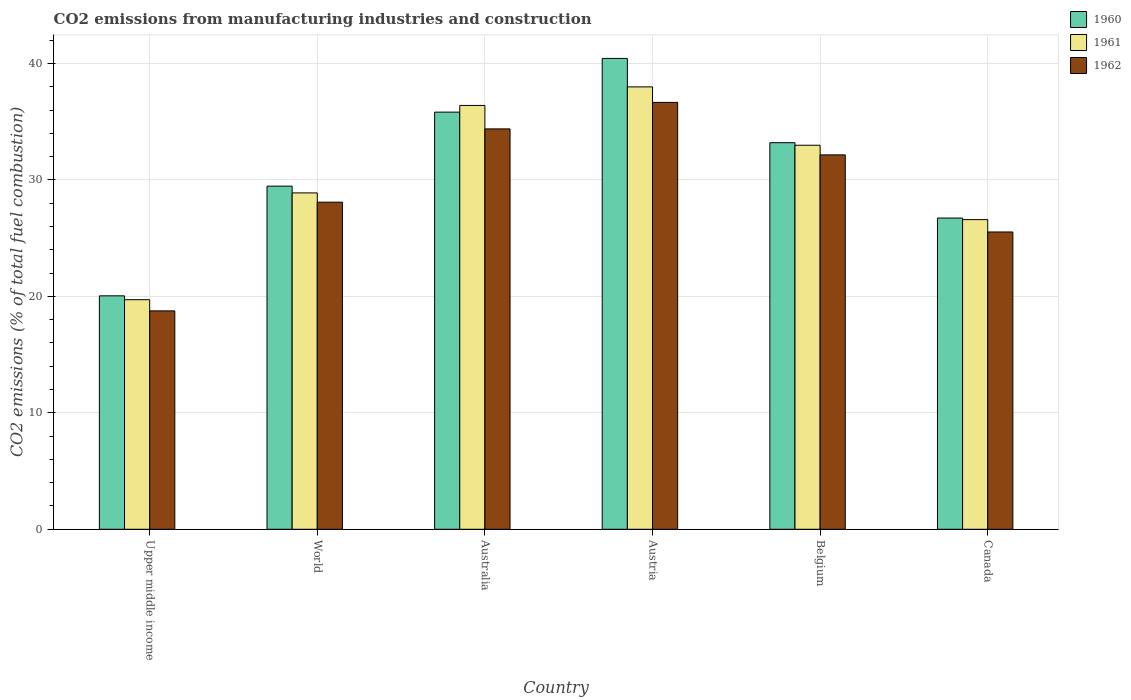How many different coloured bars are there?
Ensure brevity in your answer.  3. How many groups of bars are there?
Offer a very short reply. 6. Are the number of bars on each tick of the X-axis equal?
Provide a succinct answer. Yes. What is the amount of CO2 emitted in 1960 in Australia?
Your response must be concise. 35.83. Across all countries, what is the maximum amount of CO2 emitted in 1960?
Your answer should be compact. 40.44. Across all countries, what is the minimum amount of CO2 emitted in 1960?
Keep it short and to the point. 20.05. In which country was the amount of CO2 emitted in 1962 minimum?
Your answer should be very brief. Upper middle income. What is the total amount of CO2 emitted in 1961 in the graph?
Your answer should be very brief. 182.58. What is the difference between the amount of CO2 emitted in 1960 in Australia and that in Canada?
Your response must be concise. 9.1. What is the difference between the amount of CO2 emitted in 1962 in Australia and the amount of CO2 emitted in 1960 in Canada?
Provide a succinct answer. 7.65. What is the average amount of CO2 emitted in 1960 per country?
Make the answer very short. 30.95. What is the difference between the amount of CO2 emitted of/in 1962 and amount of CO2 emitted of/in 1960 in Austria?
Your response must be concise. -3.78. What is the ratio of the amount of CO2 emitted in 1961 in Australia to that in Austria?
Make the answer very short. 0.96. Is the difference between the amount of CO2 emitted in 1962 in Austria and Upper middle income greater than the difference between the amount of CO2 emitted in 1960 in Austria and Upper middle income?
Offer a terse response. No. What is the difference between the highest and the second highest amount of CO2 emitted in 1961?
Provide a succinct answer. -3.42. What is the difference between the highest and the lowest amount of CO2 emitted in 1962?
Your response must be concise. 17.9. In how many countries, is the amount of CO2 emitted in 1961 greater than the average amount of CO2 emitted in 1961 taken over all countries?
Provide a succinct answer. 3. What does the 2nd bar from the left in Australia represents?
Offer a very short reply. 1961. How many bars are there?
Provide a succinct answer. 18. Are all the bars in the graph horizontal?
Your answer should be very brief. No. How many countries are there in the graph?
Provide a succinct answer. 6. Does the graph contain grids?
Give a very brief answer. Yes. How are the legend labels stacked?
Provide a succinct answer. Vertical. What is the title of the graph?
Offer a terse response. CO2 emissions from manufacturing industries and construction. Does "2012" appear as one of the legend labels in the graph?
Provide a short and direct response. No. What is the label or title of the X-axis?
Make the answer very short. Country. What is the label or title of the Y-axis?
Give a very brief answer. CO2 emissions (% of total fuel combustion). What is the CO2 emissions (% of total fuel combustion) in 1960 in Upper middle income?
Your response must be concise. 20.05. What is the CO2 emissions (% of total fuel combustion) of 1961 in Upper middle income?
Your response must be concise. 19.72. What is the CO2 emissions (% of total fuel combustion) in 1962 in Upper middle income?
Provide a succinct answer. 18.76. What is the CO2 emissions (% of total fuel combustion) in 1960 in World?
Your response must be concise. 29.47. What is the CO2 emissions (% of total fuel combustion) of 1961 in World?
Provide a short and direct response. 28.89. What is the CO2 emissions (% of total fuel combustion) in 1962 in World?
Make the answer very short. 28.09. What is the CO2 emissions (% of total fuel combustion) in 1960 in Australia?
Ensure brevity in your answer.  35.83. What is the CO2 emissions (% of total fuel combustion) of 1961 in Australia?
Make the answer very short. 36.4. What is the CO2 emissions (% of total fuel combustion) in 1962 in Australia?
Your answer should be very brief. 34.39. What is the CO2 emissions (% of total fuel combustion) in 1960 in Austria?
Offer a very short reply. 40.44. What is the CO2 emissions (% of total fuel combustion) in 1961 in Austria?
Make the answer very short. 37.99. What is the CO2 emissions (% of total fuel combustion) of 1962 in Austria?
Your response must be concise. 36.66. What is the CO2 emissions (% of total fuel combustion) of 1960 in Belgium?
Your answer should be compact. 33.2. What is the CO2 emissions (% of total fuel combustion) in 1961 in Belgium?
Make the answer very short. 32.98. What is the CO2 emissions (% of total fuel combustion) of 1962 in Belgium?
Offer a very short reply. 32.16. What is the CO2 emissions (% of total fuel combustion) in 1960 in Canada?
Your answer should be compact. 26.73. What is the CO2 emissions (% of total fuel combustion) in 1961 in Canada?
Your response must be concise. 26.59. What is the CO2 emissions (% of total fuel combustion) of 1962 in Canada?
Provide a short and direct response. 25.53. Across all countries, what is the maximum CO2 emissions (% of total fuel combustion) in 1960?
Offer a very short reply. 40.44. Across all countries, what is the maximum CO2 emissions (% of total fuel combustion) in 1961?
Your answer should be compact. 37.99. Across all countries, what is the maximum CO2 emissions (% of total fuel combustion) in 1962?
Offer a terse response. 36.66. Across all countries, what is the minimum CO2 emissions (% of total fuel combustion) of 1960?
Provide a succinct answer. 20.05. Across all countries, what is the minimum CO2 emissions (% of total fuel combustion) in 1961?
Your answer should be compact. 19.72. Across all countries, what is the minimum CO2 emissions (% of total fuel combustion) of 1962?
Offer a very short reply. 18.76. What is the total CO2 emissions (% of total fuel combustion) in 1960 in the graph?
Give a very brief answer. 185.71. What is the total CO2 emissions (% of total fuel combustion) in 1961 in the graph?
Your response must be concise. 182.58. What is the total CO2 emissions (% of total fuel combustion) in 1962 in the graph?
Offer a very short reply. 175.59. What is the difference between the CO2 emissions (% of total fuel combustion) in 1960 in Upper middle income and that in World?
Make the answer very short. -9.42. What is the difference between the CO2 emissions (% of total fuel combustion) of 1961 in Upper middle income and that in World?
Your response must be concise. -9.17. What is the difference between the CO2 emissions (% of total fuel combustion) of 1962 in Upper middle income and that in World?
Offer a very short reply. -9.34. What is the difference between the CO2 emissions (% of total fuel combustion) in 1960 in Upper middle income and that in Australia?
Give a very brief answer. -15.78. What is the difference between the CO2 emissions (% of total fuel combustion) of 1961 in Upper middle income and that in Australia?
Offer a terse response. -16.68. What is the difference between the CO2 emissions (% of total fuel combustion) in 1962 in Upper middle income and that in Australia?
Provide a succinct answer. -15.63. What is the difference between the CO2 emissions (% of total fuel combustion) of 1960 in Upper middle income and that in Austria?
Offer a terse response. -20.39. What is the difference between the CO2 emissions (% of total fuel combustion) in 1961 in Upper middle income and that in Austria?
Your response must be concise. -18.28. What is the difference between the CO2 emissions (% of total fuel combustion) in 1962 in Upper middle income and that in Austria?
Offer a very short reply. -17.9. What is the difference between the CO2 emissions (% of total fuel combustion) in 1960 in Upper middle income and that in Belgium?
Make the answer very short. -13.15. What is the difference between the CO2 emissions (% of total fuel combustion) of 1961 in Upper middle income and that in Belgium?
Your response must be concise. -13.27. What is the difference between the CO2 emissions (% of total fuel combustion) of 1962 in Upper middle income and that in Belgium?
Offer a very short reply. -13.4. What is the difference between the CO2 emissions (% of total fuel combustion) in 1960 in Upper middle income and that in Canada?
Your response must be concise. -6.68. What is the difference between the CO2 emissions (% of total fuel combustion) in 1961 in Upper middle income and that in Canada?
Your answer should be compact. -6.88. What is the difference between the CO2 emissions (% of total fuel combustion) in 1962 in Upper middle income and that in Canada?
Give a very brief answer. -6.78. What is the difference between the CO2 emissions (% of total fuel combustion) of 1960 in World and that in Australia?
Your answer should be very brief. -6.36. What is the difference between the CO2 emissions (% of total fuel combustion) of 1961 in World and that in Australia?
Provide a short and direct response. -7.51. What is the difference between the CO2 emissions (% of total fuel combustion) of 1962 in World and that in Australia?
Ensure brevity in your answer.  -6.29. What is the difference between the CO2 emissions (% of total fuel combustion) in 1960 in World and that in Austria?
Your answer should be very brief. -10.97. What is the difference between the CO2 emissions (% of total fuel combustion) in 1961 in World and that in Austria?
Keep it short and to the point. -9.11. What is the difference between the CO2 emissions (% of total fuel combustion) in 1962 in World and that in Austria?
Offer a very short reply. -8.57. What is the difference between the CO2 emissions (% of total fuel combustion) in 1960 in World and that in Belgium?
Ensure brevity in your answer.  -3.73. What is the difference between the CO2 emissions (% of total fuel combustion) of 1961 in World and that in Belgium?
Offer a very short reply. -4.09. What is the difference between the CO2 emissions (% of total fuel combustion) in 1962 in World and that in Belgium?
Your response must be concise. -4.06. What is the difference between the CO2 emissions (% of total fuel combustion) of 1960 in World and that in Canada?
Make the answer very short. 2.74. What is the difference between the CO2 emissions (% of total fuel combustion) in 1961 in World and that in Canada?
Offer a very short reply. 2.29. What is the difference between the CO2 emissions (% of total fuel combustion) in 1962 in World and that in Canada?
Provide a succinct answer. 2.56. What is the difference between the CO2 emissions (% of total fuel combustion) in 1960 in Australia and that in Austria?
Provide a short and direct response. -4.61. What is the difference between the CO2 emissions (% of total fuel combustion) of 1961 in Australia and that in Austria?
Offer a very short reply. -1.6. What is the difference between the CO2 emissions (% of total fuel combustion) in 1962 in Australia and that in Austria?
Give a very brief answer. -2.28. What is the difference between the CO2 emissions (% of total fuel combustion) of 1960 in Australia and that in Belgium?
Offer a terse response. 2.63. What is the difference between the CO2 emissions (% of total fuel combustion) of 1961 in Australia and that in Belgium?
Your response must be concise. 3.42. What is the difference between the CO2 emissions (% of total fuel combustion) in 1962 in Australia and that in Belgium?
Offer a very short reply. 2.23. What is the difference between the CO2 emissions (% of total fuel combustion) of 1960 in Australia and that in Canada?
Your response must be concise. 9.1. What is the difference between the CO2 emissions (% of total fuel combustion) in 1961 in Australia and that in Canada?
Make the answer very short. 9.81. What is the difference between the CO2 emissions (% of total fuel combustion) of 1962 in Australia and that in Canada?
Provide a succinct answer. 8.85. What is the difference between the CO2 emissions (% of total fuel combustion) of 1960 in Austria and that in Belgium?
Ensure brevity in your answer.  7.24. What is the difference between the CO2 emissions (% of total fuel combustion) in 1961 in Austria and that in Belgium?
Your response must be concise. 5.01. What is the difference between the CO2 emissions (% of total fuel combustion) in 1962 in Austria and that in Belgium?
Your response must be concise. 4.51. What is the difference between the CO2 emissions (% of total fuel combustion) in 1960 in Austria and that in Canada?
Your response must be concise. 13.71. What is the difference between the CO2 emissions (% of total fuel combustion) of 1961 in Austria and that in Canada?
Ensure brevity in your answer.  11.4. What is the difference between the CO2 emissions (% of total fuel combustion) in 1962 in Austria and that in Canada?
Make the answer very short. 11.13. What is the difference between the CO2 emissions (% of total fuel combustion) of 1960 in Belgium and that in Canada?
Your answer should be compact. 6.47. What is the difference between the CO2 emissions (% of total fuel combustion) of 1961 in Belgium and that in Canada?
Keep it short and to the point. 6.39. What is the difference between the CO2 emissions (% of total fuel combustion) in 1962 in Belgium and that in Canada?
Your answer should be compact. 6.62. What is the difference between the CO2 emissions (% of total fuel combustion) of 1960 in Upper middle income and the CO2 emissions (% of total fuel combustion) of 1961 in World?
Provide a succinct answer. -8.84. What is the difference between the CO2 emissions (% of total fuel combustion) of 1960 in Upper middle income and the CO2 emissions (% of total fuel combustion) of 1962 in World?
Your answer should be compact. -8.04. What is the difference between the CO2 emissions (% of total fuel combustion) in 1961 in Upper middle income and the CO2 emissions (% of total fuel combustion) in 1962 in World?
Offer a terse response. -8.38. What is the difference between the CO2 emissions (% of total fuel combustion) in 1960 in Upper middle income and the CO2 emissions (% of total fuel combustion) in 1961 in Australia?
Give a very brief answer. -16.35. What is the difference between the CO2 emissions (% of total fuel combustion) of 1960 in Upper middle income and the CO2 emissions (% of total fuel combustion) of 1962 in Australia?
Ensure brevity in your answer.  -14.34. What is the difference between the CO2 emissions (% of total fuel combustion) of 1961 in Upper middle income and the CO2 emissions (% of total fuel combustion) of 1962 in Australia?
Provide a succinct answer. -14.67. What is the difference between the CO2 emissions (% of total fuel combustion) in 1960 in Upper middle income and the CO2 emissions (% of total fuel combustion) in 1961 in Austria?
Offer a terse response. -17.95. What is the difference between the CO2 emissions (% of total fuel combustion) of 1960 in Upper middle income and the CO2 emissions (% of total fuel combustion) of 1962 in Austria?
Keep it short and to the point. -16.61. What is the difference between the CO2 emissions (% of total fuel combustion) of 1961 in Upper middle income and the CO2 emissions (% of total fuel combustion) of 1962 in Austria?
Ensure brevity in your answer.  -16.95. What is the difference between the CO2 emissions (% of total fuel combustion) in 1960 in Upper middle income and the CO2 emissions (% of total fuel combustion) in 1961 in Belgium?
Your answer should be compact. -12.93. What is the difference between the CO2 emissions (% of total fuel combustion) in 1960 in Upper middle income and the CO2 emissions (% of total fuel combustion) in 1962 in Belgium?
Offer a terse response. -12.11. What is the difference between the CO2 emissions (% of total fuel combustion) in 1961 in Upper middle income and the CO2 emissions (% of total fuel combustion) in 1962 in Belgium?
Make the answer very short. -12.44. What is the difference between the CO2 emissions (% of total fuel combustion) in 1960 in Upper middle income and the CO2 emissions (% of total fuel combustion) in 1961 in Canada?
Provide a short and direct response. -6.55. What is the difference between the CO2 emissions (% of total fuel combustion) of 1960 in Upper middle income and the CO2 emissions (% of total fuel combustion) of 1962 in Canada?
Ensure brevity in your answer.  -5.48. What is the difference between the CO2 emissions (% of total fuel combustion) of 1961 in Upper middle income and the CO2 emissions (% of total fuel combustion) of 1962 in Canada?
Your response must be concise. -5.82. What is the difference between the CO2 emissions (% of total fuel combustion) in 1960 in World and the CO2 emissions (% of total fuel combustion) in 1961 in Australia?
Offer a terse response. -6.93. What is the difference between the CO2 emissions (% of total fuel combustion) in 1960 in World and the CO2 emissions (% of total fuel combustion) in 1962 in Australia?
Your answer should be very brief. -4.92. What is the difference between the CO2 emissions (% of total fuel combustion) in 1961 in World and the CO2 emissions (% of total fuel combustion) in 1962 in Australia?
Provide a succinct answer. -5.5. What is the difference between the CO2 emissions (% of total fuel combustion) in 1960 in World and the CO2 emissions (% of total fuel combustion) in 1961 in Austria?
Your answer should be compact. -8.53. What is the difference between the CO2 emissions (% of total fuel combustion) of 1960 in World and the CO2 emissions (% of total fuel combustion) of 1962 in Austria?
Your response must be concise. -7.19. What is the difference between the CO2 emissions (% of total fuel combustion) of 1961 in World and the CO2 emissions (% of total fuel combustion) of 1962 in Austria?
Your response must be concise. -7.77. What is the difference between the CO2 emissions (% of total fuel combustion) of 1960 in World and the CO2 emissions (% of total fuel combustion) of 1961 in Belgium?
Ensure brevity in your answer.  -3.51. What is the difference between the CO2 emissions (% of total fuel combustion) in 1960 in World and the CO2 emissions (% of total fuel combustion) in 1962 in Belgium?
Provide a succinct answer. -2.69. What is the difference between the CO2 emissions (% of total fuel combustion) of 1961 in World and the CO2 emissions (% of total fuel combustion) of 1962 in Belgium?
Ensure brevity in your answer.  -3.27. What is the difference between the CO2 emissions (% of total fuel combustion) of 1960 in World and the CO2 emissions (% of total fuel combustion) of 1961 in Canada?
Provide a short and direct response. 2.87. What is the difference between the CO2 emissions (% of total fuel combustion) of 1960 in World and the CO2 emissions (% of total fuel combustion) of 1962 in Canada?
Your answer should be very brief. 3.94. What is the difference between the CO2 emissions (% of total fuel combustion) of 1961 in World and the CO2 emissions (% of total fuel combustion) of 1962 in Canada?
Ensure brevity in your answer.  3.35. What is the difference between the CO2 emissions (% of total fuel combustion) in 1960 in Australia and the CO2 emissions (% of total fuel combustion) in 1961 in Austria?
Ensure brevity in your answer.  -2.17. What is the difference between the CO2 emissions (% of total fuel combustion) in 1960 in Australia and the CO2 emissions (% of total fuel combustion) in 1962 in Austria?
Your response must be concise. -0.84. What is the difference between the CO2 emissions (% of total fuel combustion) of 1961 in Australia and the CO2 emissions (% of total fuel combustion) of 1962 in Austria?
Offer a terse response. -0.26. What is the difference between the CO2 emissions (% of total fuel combustion) in 1960 in Australia and the CO2 emissions (% of total fuel combustion) in 1961 in Belgium?
Ensure brevity in your answer.  2.84. What is the difference between the CO2 emissions (% of total fuel combustion) in 1960 in Australia and the CO2 emissions (% of total fuel combustion) in 1962 in Belgium?
Provide a short and direct response. 3.67. What is the difference between the CO2 emissions (% of total fuel combustion) in 1961 in Australia and the CO2 emissions (% of total fuel combustion) in 1962 in Belgium?
Give a very brief answer. 4.24. What is the difference between the CO2 emissions (% of total fuel combustion) in 1960 in Australia and the CO2 emissions (% of total fuel combustion) in 1961 in Canada?
Your answer should be compact. 9.23. What is the difference between the CO2 emissions (% of total fuel combustion) of 1960 in Australia and the CO2 emissions (% of total fuel combustion) of 1962 in Canada?
Make the answer very short. 10.29. What is the difference between the CO2 emissions (% of total fuel combustion) of 1961 in Australia and the CO2 emissions (% of total fuel combustion) of 1962 in Canada?
Your answer should be compact. 10.87. What is the difference between the CO2 emissions (% of total fuel combustion) of 1960 in Austria and the CO2 emissions (% of total fuel combustion) of 1961 in Belgium?
Your answer should be compact. 7.46. What is the difference between the CO2 emissions (% of total fuel combustion) in 1960 in Austria and the CO2 emissions (% of total fuel combustion) in 1962 in Belgium?
Make the answer very short. 8.28. What is the difference between the CO2 emissions (% of total fuel combustion) of 1961 in Austria and the CO2 emissions (% of total fuel combustion) of 1962 in Belgium?
Ensure brevity in your answer.  5.84. What is the difference between the CO2 emissions (% of total fuel combustion) in 1960 in Austria and the CO2 emissions (% of total fuel combustion) in 1961 in Canada?
Your answer should be compact. 13.84. What is the difference between the CO2 emissions (% of total fuel combustion) in 1960 in Austria and the CO2 emissions (% of total fuel combustion) in 1962 in Canada?
Make the answer very short. 14.91. What is the difference between the CO2 emissions (% of total fuel combustion) of 1961 in Austria and the CO2 emissions (% of total fuel combustion) of 1962 in Canada?
Your answer should be compact. 12.46. What is the difference between the CO2 emissions (% of total fuel combustion) of 1960 in Belgium and the CO2 emissions (% of total fuel combustion) of 1961 in Canada?
Offer a terse response. 6.61. What is the difference between the CO2 emissions (% of total fuel combustion) in 1960 in Belgium and the CO2 emissions (% of total fuel combustion) in 1962 in Canada?
Keep it short and to the point. 7.67. What is the difference between the CO2 emissions (% of total fuel combustion) of 1961 in Belgium and the CO2 emissions (% of total fuel combustion) of 1962 in Canada?
Offer a terse response. 7.45. What is the average CO2 emissions (% of total fuel combustion) in 1960 per country?
Keep it short and to the point. 30.95. What is the average CO2 emissions (% of total fuel combustion) in 1961 per country?
Give a very brief answer. 30.43. What is the average CO2 emissions (% of total fuel combustion) in 1962 per country?
Provide a succinct answer. 29.26. What is the difference between the CO2 emissions (% of total fuel combustion) of 1960 and CO2 emissions (% of total fuel combustion) of 1961 in Upper middle income?
Make the answer very short. 0.33. What is the difference between the CO2 emissions (% of total fuel combustion) of 1960 and CO2 emissions (% of total fuel combustion) of 1962 in Upper middle income?
Keep it short and to the point. 1.29. What is the difference between the CO2 emissions (% of total fuel combustion) in 1961 and CO2 emissions (% of total fuel combustion) in 1962 in Upper middle income?
Ensure brevity in your answer.  0.96. What is the difference between the CO2 emissions (% of total fuel combustion) in 1960 and CO2 emissions (% of total fuel combustion) in 1961 in World?
Your answer should be compact. 0.58. What is the difference between the CO2 emissions (% of total fuel combustion) of 1960 and CO2 emissions (% of total fuel combustion) of 1962 in World?
Ensure brevity in your answer.  1.38. What is the difference between the CO2 emissions (% of total fuel combustion) in 1961 and CO2 emissions (% of total fuel combustion) in 1962 in World?
Provide a succinct answer. 0.79. What is the difference between the CO2 emissions (% of total fuel combustion) in 1960 and CO2 emissions (% of total fuel combustion) in 1961 in Australia?
Your answer should be compact. -0.57. What is the difference between the CO2 emissions (% of total fuel combustion) in 1960 and CO2 emissions (% of total fuel combustion) in 1962 in Australia?
Offer a terse response. 1.44. What is the difference between the CO2 emissions (% of total fuel combustion) of 1961 and CO2 emissions (% of total fuel combustion) of 1962 in Australia?
Offer a terse response. 2.01. What is the difference between the CO2 emissions (% of total fuel combustion) of 1960 and CO2 emissions (% of total fuel combustion) of 1961 in Austria?
Give a very brief answer. 2.44. What is the difference between the CO2 emissions (% of total fuel combustion) in 1960 and CO2 emissions (% of total fuel combustion) in 1962 in Austria?
Offer a terse response. 3.78. What is the difference between the CO2 emissions (% of total fuel combustion) of 1961 and CO2 emissions (% of total fuel combustion) of 1962 in Austria?
Give a very brief answer. 1.33. What is the difference between the CO2 emissions (% of total fuel combustion) in 1960 and CO2 emissions (% of total fuel combustion) in 1961 in Belgium?
Your response must be concise. 0.22. What is the difference between the CO2 emissions (% of total fuel combustion) of 1960 and CO2 emissions (% of total fuel combustion) of 1962 in Belgium?
Offer a very short reply. 1.04. What is the difference between the CO2 emissions (% of total fuel combustion) in 1961 and CO2 emissions (% of total fuel combustion) in 1962 in Belgium?
Give a very brief answer. 0.83. What is the difference between the CO2 emissions (% of total fuel combustion) of 1960 and CO2 emissions (% of total fuel combustion) of 1961 in Canada?
Offer a terse response. 0.14. What is the difference between the CO2 emissions (% of total fuel combustion) in 1960 and CO2 emissions (% of total fuel combustion) in 1962 in Canada?
Offer a very short reply. 1.2. What is the difference between the CO2 emissions (% of total fuel combustion) of 1961 and CO2 emissions (% of total fuel combustion) of 1962 in Canada?
Provide a succinct answer. 1.06. What is the ratio of the CO2 emissions (% of total fuel combustion) in 1960 in Upper middle income to that in World?
Your response must be concise. 0.68. What is the ratio of the CO2 emissions (% of total fuel combustion) of 1961 in Upper middle income to that in World?
Your answer should be compact. 0.68. What is the ratio of the CO2 emissions (% of total fuel combustion) in 1962 in Upper middle income to that in World?
Keep it short and to the point. 0.67. What is the ratio of the CO2 emissions (% of total fuel combustion) of 1960 in Upper middle income to that in Australia?
Keep it short and to the point. 0.56. What is the ratio of the CO2 emissions (% of total fuel combustion) in 1961 in Upper middle income to that in Australia?
Keep it short and to the point. 0.54. What is the ratio of the CO2 emissions (% of total fuel combustion) in 1962 in Upper middle income to that in Australia?
Provide a succinct answer. 0.55. What is the ratio of the CO2 emissions (% of total fuel combustion) in 1960 in Upper middle income to that in Austria?
Ensure brevity in your answer.  0.5. What is the ratio of the CO2 emissions (% of total fuel combustion) in 1961 in Upper middle income to that in Austria?
Ensure brevity in your answer.  0.52. What is the ratio of the CO2 emissions (% of total fuel combustion) in 1962 in Upper middle income to that in Austria?
Give a very brief answer. 0.51. What is the ratio of the CO2 emissions (% of total fuel combustion) of 1960 in Upper middle income to that in Belgium?
Your answer should be very brief. 0.6. What is the ratio of the CO2 emissions (% of total fuel combustion) in 1961 in Upper middle income to that in Belgium?
Make the answer very short. 0.6. What is the ratio of the CO2 emissions (% of total fuel combustion) in 1962 in Upper middle income to that in Belgium?
Offer a very short reply. 0.58. What is the ratio of the CO2 emissions (% of total fuel combustion) in 1960 in Upper middle income to that in Canada?
Ensure brevity in your answer.  0.75. What is the ratio of the CO2 emissions (% of total fuel combustion) of 1961 in Upper middle income to that in Canada?
Ensure brevity in your answer.  0.74. What is the ratio of the CO2 emissions (% of total fuel combustion) in 1962 in Upper middle income to that in Canada?
Your answer should be compact. 0.73. What is the ratio of the CO2 emissions (% of total fuel combustion) of 1960 in World to that in Australia?
Provide a short and direct response. 0.82. What is the ratio of the CO2 emissions (% of total fuel combustion) in 1961 in World to that in Australia?
Give a very brief answer. 0.79. What is the ratio of the CO2 emissions (% of total fuel combustion) of 1962 in World to that in Australia?
Keep it short and to the point. 0.82. What is the ratio of the CO2 emissions (% of total fuel combustion) of 1960 in World to that in Austria?
Your response must be concise. 0.73. What is the ratio of the CO2 emissions (% of total fuel combustion) in 1961 in World to that in Austria?
Provide a short and direct response. 0.76. What is the ratio of the CO2 emissions (% of total fuel combustion) of 1962 in World to that in Austria?
Ensure brevity in your answer.  0.77. What is the ratio of the CO2 emissions (% of total fuel combustion) of 1960 in World to that in Belgium?
Your response must be concise. 0.89. What is the ratio of the CO2 emissions (% of total fuel combustion) in 1961 in World to that in Belgium?
Ensure brevity in your answer.  0.88. What is the ratio of the CO2 emissions (% of total fuel combustion) of 1962 in World to that in Belgium?
Ensure brevity in your answer.  0.87. What is the ratio of the CO2 emissions (% of total fuel combustion) of 1960 in World to that in Canada?
Offer a very short reply. 1.1. What is the ratio of the CO2 emissions (% of total fuel combustion) in 1961 in World to that in Canada?
Offer a very short reply. 1.09. What is the ratio of the CO2 emissions (% of total fuel combustion) in 1962 in World to that in Canada?
Keep it short and to the point. 1.1. What is the ratio of the CO2 emissions (% of total fuel combustion) in 1960 in Australia to that in Austria?
Keep it short and to the point. 0.89. What is the ratio of the CO2 emissions (% of total fuel combustion) in 1961 in Australia to that in Austria?
Offer a very short reply. 0.96. What is the ratio of the CO2 emissions (% of total fuel combustion) of 1962 in Australia to that in Austria?
Your response must be concise. 0.94. What is the ratio of the CO2 emissions (% of total fuel combustion) in 1960 in Australia to that in Belgium?
Provide a succinct answer. 1.08. What is the ratio of the CO2 emissions (% of total fuel combustion) in 1961 in Australia to that in Belgium?
Provide a short and direct response. 1.1. What is the ratio of the CO2 emissions (% of total fuel combustion) of 1962 in Australia to that in Belgium?
Give a very brief answer. 1.07. What is the ratio of the CO2 emissions (% of total fuel combustion) in 1960 in Australia to that in Canada?
Provide a succinct answer. 1.34. What is the ratio of the CO2 emissions (% of total fuel combustion) in 1961 in Australia to that in Canada?
Offer a terse response. 1.37. What is the ratio of the CO2 emissions (% of total fuel combustion) in 1962 in Australia to that in Canada?
Your response must be concise. 1.35. What is the ratio of the CO2 emissions (% of total fuel combustion) of 1960 in Austria to that in Belgium?
Provide a succinct answer. 1.22. What is the ratio of the CO2 emissions (% of total fuel combustion) of 1961 in Austria to that in Belgium?
Your response must be concise. 1.15. What is the ratio of the CO2 emissions (% of total fuel combustion) in 1962 in Austria to that in Belgium?
Provide a succinct answer. 1.14. What is the ratio of the CO2 emissions (% of total fuel combustion) of 1960 in Austria to that in Canada?
Make the answer very short. 1.51. What is the ratio of the CO2 emissions (% of total fuel combustion) of 1961 in Austria to that in Canada?
Offer a very short reply. 1.43. What is the ratio of the CO2 emissions (% of total fuel combustion) in 1962 in Austria to that in Canada?
Your answer should be very brief. 1.44. What is the ratio of the CO2 emissions (% of total fuel combustion) in 1960 in Belgium to that in Canada?
Make the answer very short. 1.24. What is the ratio of the CO2 emissions (% of total fuel combustion) of 1961 in Belgium to that in Canada?
Keep it short and to the point. 1.24. What is the ratio of the CO2 emissions (% of total fuel combustion) of 1962 in Belgium to that in Canada?
Offer a very short reply. 1.26. What is the difference between the highest and the second highest CO2 emissions (% of total fuel combustion) in 1960?
Your answer should be compact. 4.61. What is the difference between the highest and the second highest CO2 emissions (% of total fuel combustion) in 1961?
Provide a succinct answer. 1.6. What is the difference between the highest and the second highest CO2 emissions (% of total fuel combustion) of 1962?
Keep it short and to the point. 2.28. What is the difference between the highest and the lowest CO2 emissions (% of total fuel combustion) in 1960?
Offer a very short reply. 20.39. What is the difference between the highest and the lowest CO2 emissions (% of total fuel combustion) of 1961?
Your answer should be compact. 18.28. What is the difference between the highest and the lowest CO2 emissions (% of total fuel combustion) in 1962?
Provide a succinct answer. 17.9. 